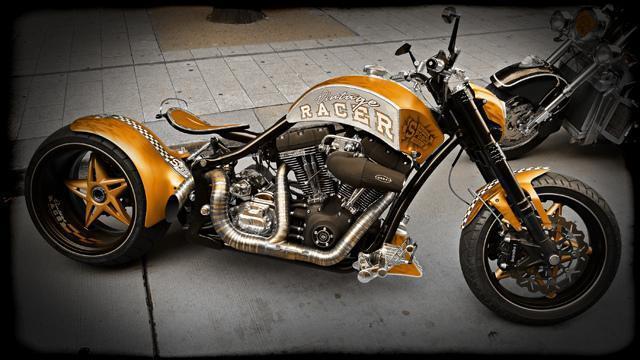How many wheels are in the picture?
Give a very brief answer. 3. How many motorcycles are in the photo?
Give a very brief answer. 2. 